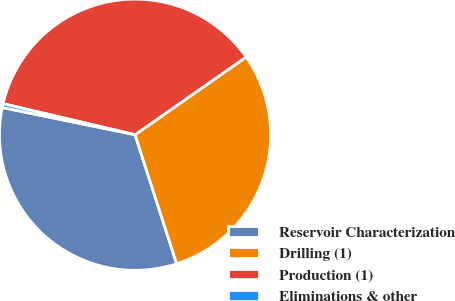Convert chart to OTSL. <chart><loc_0><loc_0><loc_500><loc_500><pie_chart><fcel>Reservoir Characterization<fcel>Drilling (1)<fcel>Production (1)<fcel>Eliminations & other<nl><fcel>33.18%<fcel>29.75%<fcel>36.61%<fcel>0.46%<nl></chart> 